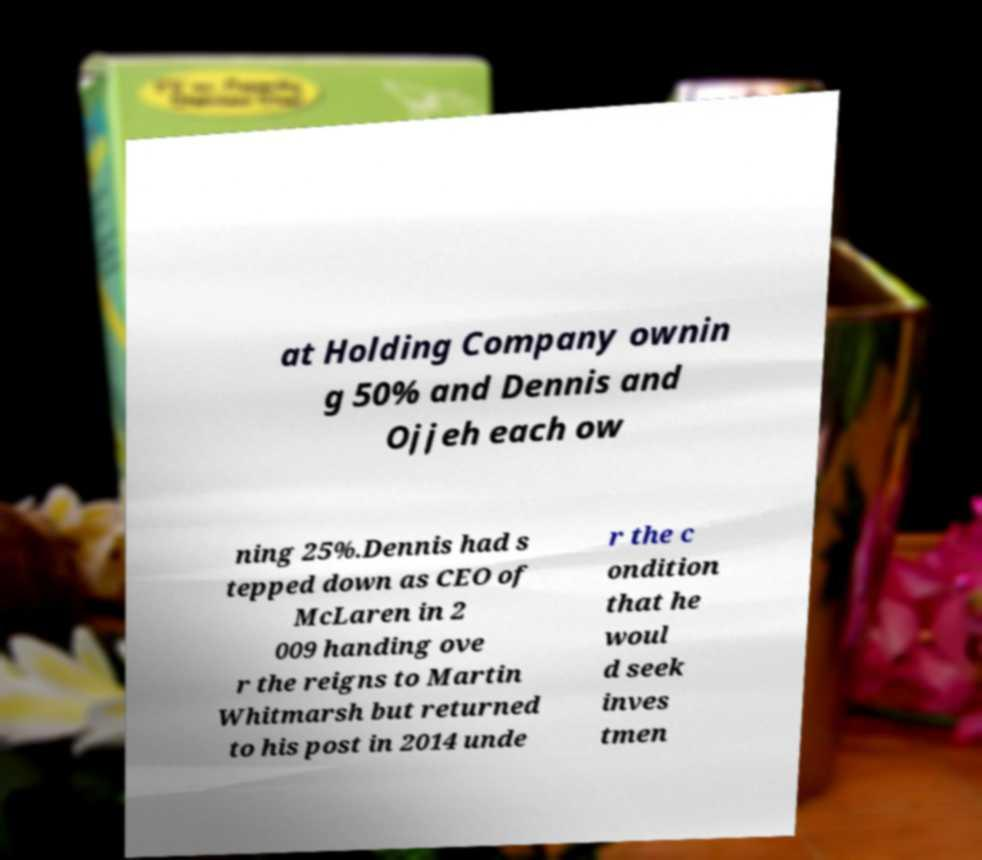Could you assist in decoding the text presented in this image and type it out clearly? at Holding Company ownin g 50% and Dennis and Ojjeh each ow ning 25%.Dennis had s tepped down as CEO of McLaren in 2 009 handing ove r the reigns to Martin Whitmarsh but returned to his post in 2014 unde r the c ondition that he woul d seek inves tmen 